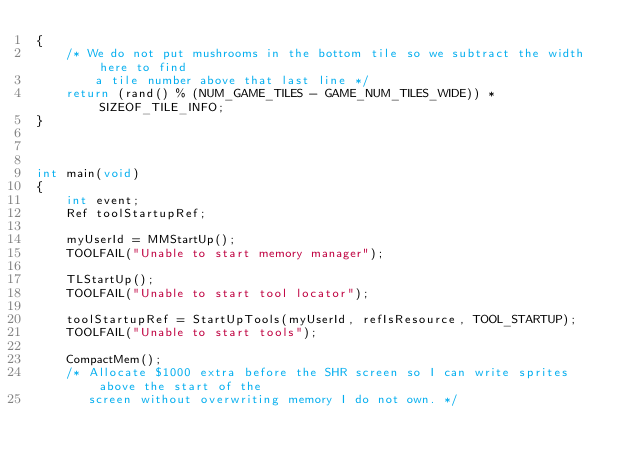Convert code to text. <code><loc_0><loc_0><loc_500><loc_500><_C_>{
    /* We do not put mushrooms in the bottom tile so we subtract the width here to find
        a tile number above that last line */
    return (rand() % (NUM_GAME_TILES - GAME_NUM_TILES_WIDE)) * SIZEOF_TILE_INFO;
}



int main(void)
{
    int event;
    Ref toolStartupRef;
    
    myUserId = MMStartUp();
    TOOLFAIL("Unable to start memory manager");
    
    TLStartUp();
    TOOLFAIL("Unable to start tool locator");
    
    toolStartupRef = StartUpTools(myUserId, refIsResource, TOOL_STARTUP);
    TOOLFAIL("Unable to start tools");
    
    CompactMem();
    /* Allocate $1000 extra before the SHR screen so I can write sprites above the start of the
       screen without overwriting memory I do not own. */</code> 